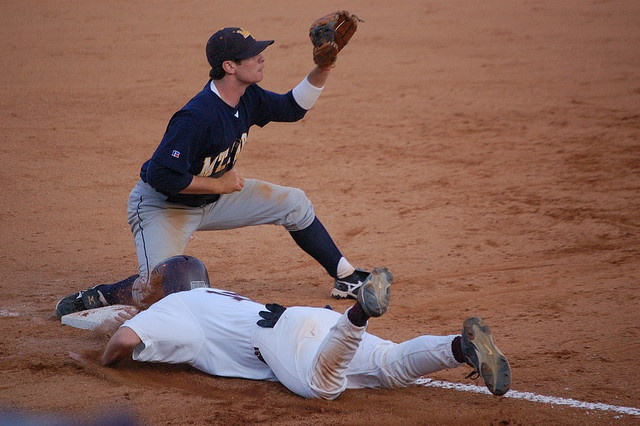Describe the objects in this image and their specific colors. I can see people in brown, black, darkgray, and gray tones, people in brown, darkgray, lavender, and gray tones, and baseball glove in brown, maroon, black, and gray tones in this image. 